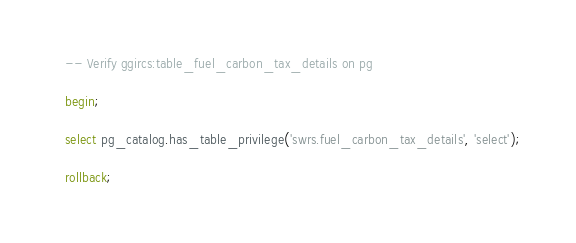<code> <loc_0><loc_0><loc_500><loc_500><_SQL_>-- Verify ggircs:table_fuel_carbon_tax_details on pg

begin;

select pg_catalog.has_table_privilege('swrs.fuel_carbon_tax_details', 'select');

rollback;
</code> 